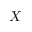Convert formula to latex. <formula><loc_0><loc_0><loc_500><loc_500>X</formula> 